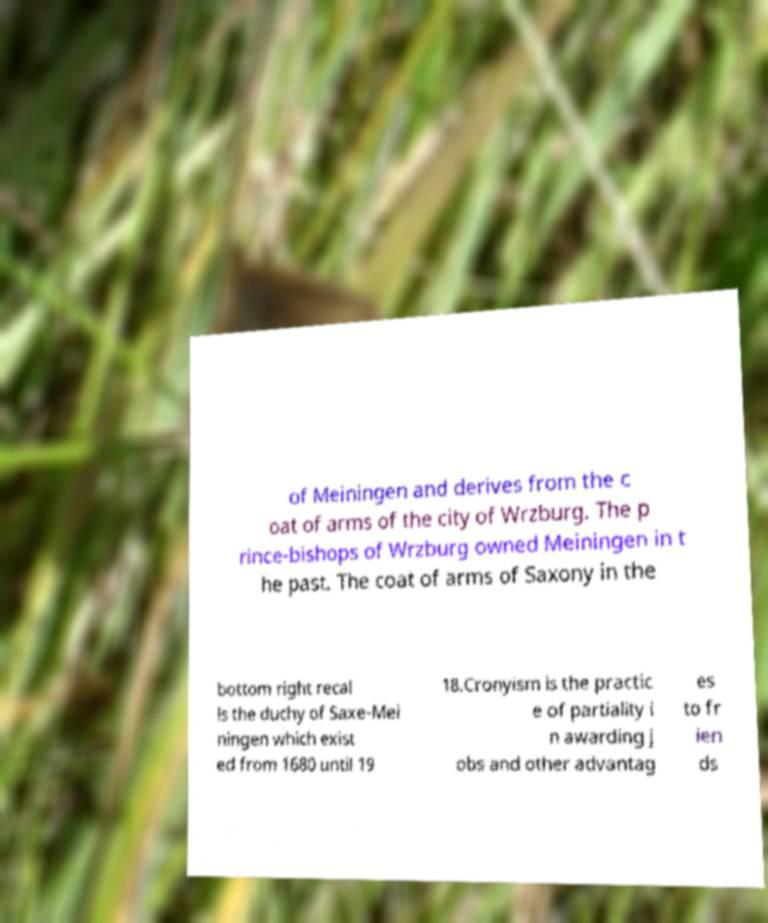I need the written content from this picture converted into text. Can you do that? of Meiningen and derives from the c oat of arms of the city of Wrzburg. The p rince-bishops of Wrzburg owned Meiningen in t he past. The coat of arms of Saxony in the bottom right recal ls the duchy of Saxe-Mei ningen which exist ed from 1680 until 19 18.Cronyism is the practic e of partiality i n awarding j obs and other advantag es to fr ien ds 